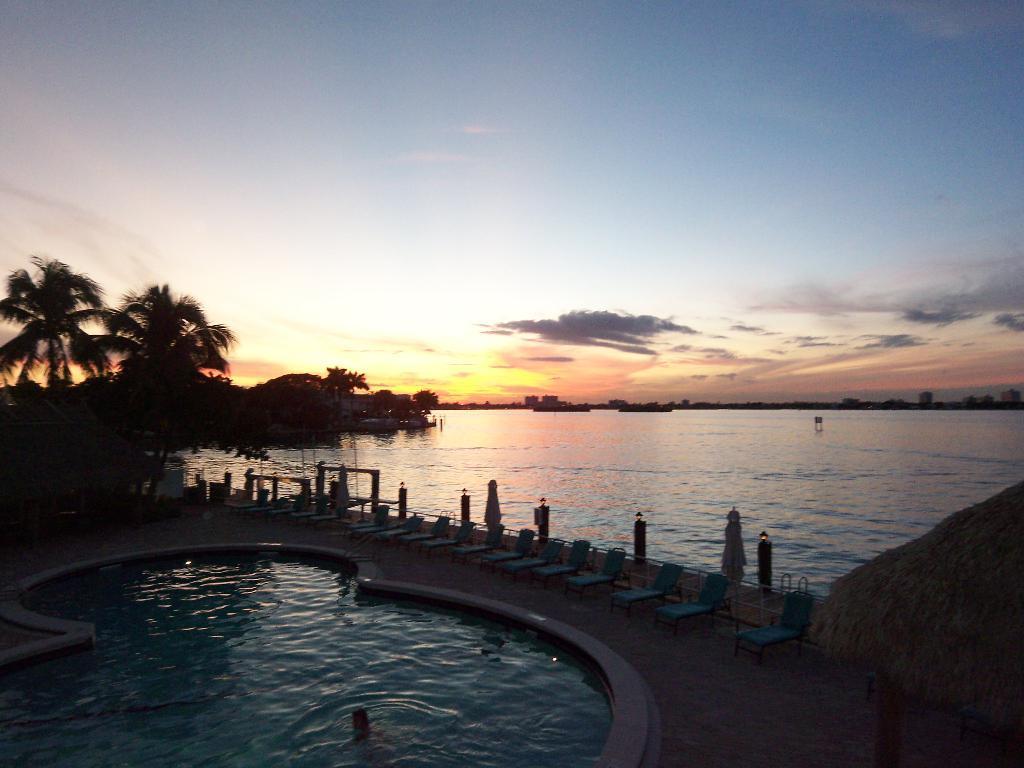How would you summarize this image in a sentence or two? In this picture we can see a swimming pool where one person is in the swimming pool and aside to this swimming pool we can see chairs and umbrellas closed and beside to this we have a water, trees and above this we there is sky with clouds and on right side we can see hut with grass. 